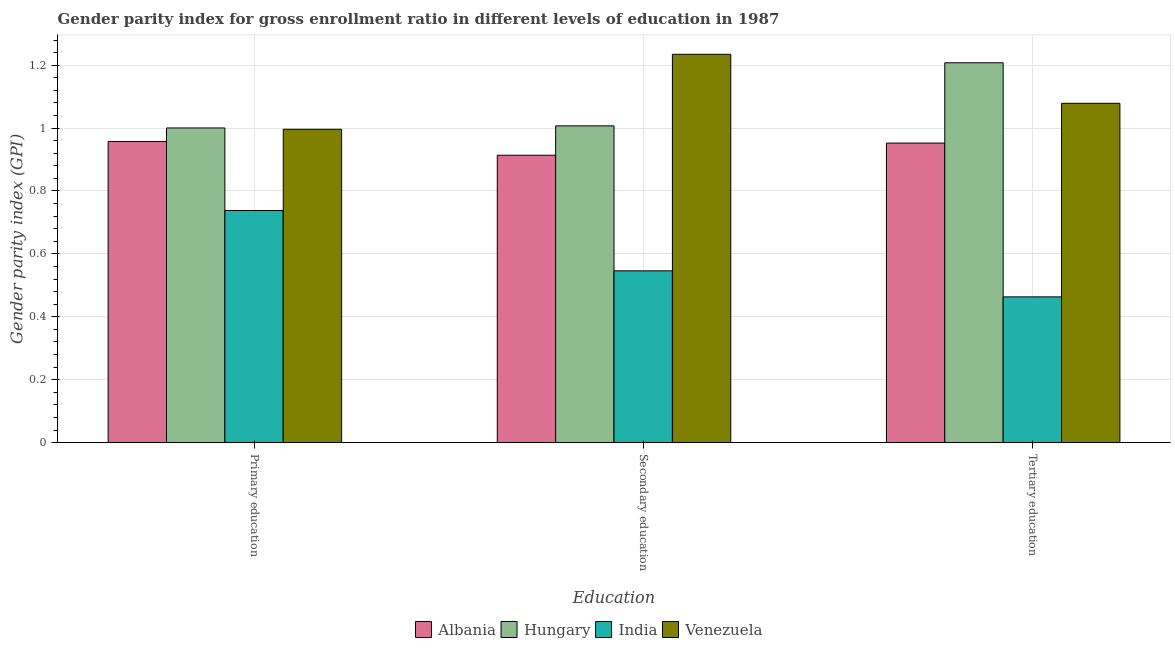How many different coloured bars are there?
Make the answer very short. 4. How many groups of bars are there?
Give a very brief answer. 3. Are the number of bars on each tick of the X-axis equal?
Provide a short and direct response. Yes. How many bars are there on the 2nd tick from the left?
Provide a succinct answer. 4. How many bars are there on the 2nd tick from the right?
Offer a terse response. 4. Across all countries, what is the maximum gender parity index in tertiary education?
Keep it short and to the point. 1.21. Across all countries, what is the minimum gender parity index in primary education?
Provide a short and direct response. 0.74. In which country was the gender parity index in tertiary education maximum?
Keep it short and to the point. Hungary. What is the total gender parity index in tertiary education in the graph?
Keep it short and to the point. 3.7. What is the difference between the gender parity index in secondary education in Albania and that in Hungary?
Provide a succinct answer. -0.09. What is the difference between the gender parity index in tertiary education in Hungary and the gender parity index in primary education in India?
Offer a very short reply. 0.47. What is the average gender parity index in primary education per country?
Your answer should be compact. 0.92. What is the difference between the gender parity index in primary education and gender parity index in tertiary education in Albania?
Give a very brief answer. 0.01. What is the ratio of the gender parity index in primary education in India to that in Albania?
Your response must be concise. 0.77. Is the gender parity index in secondary education in Venezuela less than that in Hungary?
Provide a short and direct response. No. What is the difference between the highest and the second highest gender parity index in tertiary education?
Your response must be concise. 0.13. What is the difference between the highest and the lowest gender parity index in tertiary education?
Give a very brief answer. 0.74. In how many countries, is the gender parity index in primary education greater than the average gender parity index in primary education taken over all countries?
Your answer should be very brief. 3. Is the sum of the gender parity index in secondary education in India and Venezuela greater than the maximum gender parity index in primary education across all countries?
Provide a short and direct response. Yes. What does the 3rd bar from the right in Primary education represents?
Your response must be concise. Hungary. Is it the case that in every country, the sum of the gender parity index in primary education and gender parity index in secondary education is greater than the gender parity index in tertiary education?
Keep it short and to the point. Yes. How many bars are there?
Your answer should be very brief. 12. Are all the bars in the graph horizontal?
Your answer should be compact. No. How many countries are there in the graph?
Offer a very short reply. 4. What is the difference between two consecutive major ticks on the Y-axis?
Offer a very short reply. 0.2. Are the values on the major ticks of Y-axis written in scientific E-notation?
Offer a very short reply. No. Does the graph contain any zero values?
Keep it short and to the point. No. Does the graph contain grids?
Offer a very short reply. Yes. Where does the legend appear in the graph?
Ensure brevity in your answer.  Bottom center. How are the legend labels stacked?
Your response must be concise. Horizontal. What is the title of the graph?
Give a very brief answer. Gender parity index for gross enrollment ratio in different levels of education in 1987. What is the label or title of the X-axis?
Your response must be concise. Education. What is the label or title of the Y-axis?
Give a very brief answer. Gender parity index (GPI). What is the Gender parity index (GPI) of Albania in Primary education?
Provide a short and direct response. 0.96. What is the Gender parity index (GPI) in Hungary in Primary education?
Offer a very short reply. 1. What is the Gender parity index (GPI) in India in Primary education?
Provide a short and direct response. 0.74. What is the Gender parity index (GPI) in Venezuela in Primary education?
Your answer should be very brief. 1. What is the Gender parity index (GPI) in Albania in Secondary education?
Make the answer very short. 0.91. What is the Gender parity index (GPI) in Hungary in Secondary education?
Offer a very short reply. 1.01. What is the Gender parity index (GPI) of India in Secondary education?
Offer a very short reply. 0.55. What is the Gender parity index (GPI) of Venezuela in Secondary education?
Your response must be concise. 1.23. What is the Gender parity index (GPI) of Albania in Tertiary education?
Ensure brevity in your answer.  0.95. What is the Gender parity index (GPI) of Hungary in Tertiary education?
Offer a very short reply. 1.21. What is the Gender parity index (GPI) of India in Tertiary education?
Provide a short and direct response. 0.46. What is the Gender parity index (GPI) of Venezuela in Tertiary education?
Your answer should be very brief. 1.08. Across all Education, what is the maximum Gender parity index (GPI) of Albania?
Your answer should be very brief. 0.96. Across all Education, what is the maximum Gender parity index (GPI) in Hungary?
Give a very brief answer. 1.21. Across all Education, what is the maximum Gender parity index (GPI) of India?
Your response must be concise. 0.74. Across all Education, what is the maximum Gender parity index (GPI) in Venezuela?
Your answer should be compact. 1.23. Across all Education, what is the minimum Gender parity index (GPI) in Albania?
Keep it short and to the point. 0.91. Across all Education, what is the minimum Gender parity index (GPI) of Hungary?
Offer a very short reply. 1. Across all Education, what is the minimum Gender parity index (GPI) in India?
Your answer should be compact. 0.46. Across all Education, what is the minimum Gender parity index (GPI) of Venezuela?
Offer a very short reply. 1. What is the total Gender parity index (GPI) in Albania in the graph?
Your answer should be very brief. 2.82. What is the total Gender parity index (GPI) in Hungary in the graph?
Provide a succinct answer. 3.22. What is the total Gender parity index (GPI) in India in the graph?
Make the answer very short. 1.75. What is the total Gender parity index (GPI) of Venezuela in the graph?
Provide a succinct answer. 3.31. What is the difference between the Gender parity index (GPI) in Albania in Primary education and that in Secondary education?
Provide a succinct answer. 0.04. What is the difference between the Gender parity index (GPI) of Hungary in Primary education and that in Secondary education?
Offer a terse response. -0.01. What is the difference between the Gender parity index (GPI) in India in Primary education and that in Secondary education?
Offer a terse response. 0.19. What is the difference between the Gender parity index (GPI) in Venezuela in Primary education and that in Secondary education?
Keep it short and to the point. -0.24. What is the difference between the Gender parity index (GPI) of Albania in Primary education and that in Tertiary education?
Offer a very short reply. 0.01. What is the difference between the Gender parity index (GPI) in Hungary in Primary education and that in Tertiary education?
Give a very brief answer. -0.21. What is the difference between the Gender parity index (GPI) of India in Primary education and that in Tertiary education?
Provide a short and direct response. 0.27. What is the difference between the Gender parity index (GPI) in Venezuela in Primary education and that in Tertiary education?
Provide a succinct answer. -0.08. What is the difference between the Gender parity index (GPI) in Albania in Secondary education and that in Tertiary education?
Keep it short and to the point. -0.04. What is the difference between the Gender parity index (GPI) of Hungary in Secondary education and that in Tertiary education?
Your response must be concise. -0.2. What is the difference between the Gender parity index (GPI) in India in Secondary education and that in Tertiary education?
Give a very brief answer. 0.08. What is the difference between the Gender parity index (GPI) of Venezuela in Secondary education and that in Tertiary education?
Your answer should be compact. 0.16. What is the difference between the Gender parity index (GPI) in Albania in Primary education and the Gender parity index (GPI) in Hungary in Secondary education?
Make the answer very short. -0.05. What is the difference between the Gender parity index (GPI) in Albania in Primary education and the Gender parity index (GPI) in India in Secondary education?
Your response must be concise. 0.41. What is the difference between the Gender parity index (GPI) in Albania in Primary education and the Gender parity index (GPI) in Venezuela in Secondary education?
Offer a very short reply. -0.28. What is the difference between the Gender parity index (GPI) of Hungary in Primary education and the Gender parity index (GPI) of India in Secondary education?
Make the answer very short. 0.45. What is the difference between the Gender parity index (GPI) in Hungary in Primary education and the Gender parity index (GPI) in Venezuela in Secondary education?
Keep it short and to the point. -0.23. What is the difference between the Gender parity index (GPI) in India in Primary education and the Gender parity index (GPI) in Venezuela in Secondary education?
Provide a succinct answer. -0.5. What is the difference between the Gender parity index (GPI) of Albania in Primary education and the Gender parity index (GPI) of Hungary in Tertiary education?
Ensure brevity in your answer.  -0.25. What is the difference between the Gender parity index (GPI) in Albania in Primary education and the Gender parity index (GPI) in India in Tertiary education?
Make the answer very short. 0.49. What is the difference between the Gender parity index (GPI) of Albania in Primary education and the Gender parity index (GPI) of Venezuela in Tertiary education?
Make the answer very short. -0.12. What is the difference between the Gender parity index (GPI) in Hungary in Primary education and the Gender parity index (GPI) in India in Tertiary education?
Ensure brevity in your answer.  0.54. What is the difference between the Gender parity index (GPI) in Hungary in Primary education and the Gender parity index (GPI) in Venezuela in Tertiary education?
Provide a succinct answer. -0.08. What is the difference between the Gender parity index (GPI) of India in Primary education and the Gender parity index (GPI) of Venezuela in Tertiary education?
Your answer should be compact. -0.34. What is the difference between the Gender parity index (GPI) in Albania in Secondary education and the Gender parity index (GPI) in Hungary in Tertiary education?
Provide a succinct answer. -0.29. What is the difference between the Gender parity index (GPI) in Albania in Secondary education and the Gender parity index (GPI) in India in Tertiary education?
Your answer should be compact. 0.45. What is the difference between the Gender parity index (GPI) in Albania in Secondary education and the Gender parity index (GPI) in Venezuela in Tertiary education?
Your answer should be very brief. -0.17. What is the difference between the Gender parity index (GPI) of Hungary in Secondary education and the Gender parity index (GPI) of India in Tertiary education?
Keep it short and to the point. 0.54. What is the difference between the Gender parity index (GPI) in Hungary in Secondary education and the Gender parity index (GPI) in Venezuela in Tertiary education?
Your answer should be very brief. -0.07. What is the difference between the Gender parity index (GPI) in India in Secondary education and the Gender parity index (GPI) in Venezuela in Tertiary education?
Your response must be concise. -0.53. What is the average Gender parity index (GPI) of Albania per Education?
Provide a short and direct response. 0.94. What is the average Gender parity index (GPI) of Hungary per Education?
Provide a short and direct response. 1.07. What is the average Gender parity index (GPI) in India per Education?
Offer a terse response. 0.58. What is the average Gender parity index (GPI) in Venezuela per Education?
Make the answer very short. 1.1. What is the difference between the Gender parity index (GPI) of Albania and Gender parity index (GPI) of Hungary in Primary education?
Provide a succinct answer. -0.04. What is the difference between the Gender parity index (GPI) in Albania and Gender parity index (GPI) in India in Primary education?
Make the answer very short. 0.22. What is the difference between the Gender parity index (GPI) in Albania and Gender parity index (GPI) in Venezuela in Primary education?
Provide a succinct answer. -0.04. What is the difference between the Gender parity index (GPI) of Hungary and Gender parity index (GPI) of India in Primary education?
Ensure brevity in your answer.  0.26. What is the difference between the Gender parity index (GPI) in Hungary and Gender parity index (GPI) in Venezuela in Primary education?
Your response must be concise. 0. What is the difference between the Gender parity index (GPI) of India and Gender parity index (GPI) of Venezuela in Primary education?
Your response must be concise. -0.26. What is the difference between the Gender parity index (GPI) of Albania and Gender parity index (GPI) of Hungary in Secondary education?
Provide a short and direct response. -0.09. What is the difference between the Gender parity index (GPI) in Albania and Gender parity index (GPI) in India in Secondary education?
Your answer should be compact. 0.37. What is the difference between the Gender parity index (GPI) in Albania and Gender parity index (GPI) in Venezuela in Secondary education?
Your answer should be compact. -0.32. What is the difference between the Gender parity index (GPI) of Hungary and Gender parity index (GPI) of India in Secondary education?
Your response must be concise. 0.46. What is the difference between the Gender parity index (GPI) in Hungary and Gender parity index (GPI) in Venezuela in Secondary education?
Offer a very short reply. -0.23. What is the difference between the Gender parity index (GPI) in India and Gender parity index (GPI) in Venezuela in Secondary education?
Provide a short and direct response. -0.69. What is the difference between the Gender parity index (GPI) of Albania and Gender parity index (GPI) of Hungary in Tertiary education?
Your response must be concise. -0.26. What is the difference between the Gender parity index (GPI) in Albania and Gender parity index (GPI) in India in Tertiary education?
Your answer should be compact. 0.49. What is the difference between the Gender parity index (GPI) of Albania and Gender parity index (GPI) of Venezuela in Tertiary education?
Your answer should be compact. -0.13. What is the difference between the Gender parity index (GPI) of Hungary and Gender parity index (GPI) of India in Tertiary education?
Keep it short and to the point. 0.74. What is the difference between the Gender parity index (GPI) in Hungary and Gender parity index (GPI) in Venezuela in Tertiary education?
Your answer should be very brief. 0.13. What is the difference between the Gender parity index (GPI) in India and Gender parity index (GPI) in Venezuela in Tertiary education?
Make the answer very short. -0.62. What is the ratio of the Gender parity index (GPI) in Albania in Primary education to that in Secondary education?
Your response must be concise. 1.05. What is the ratio of the Gender parity index (GPI) in Hungary in Primary education to that in Secondary education?
Provide a short and direct response. 0.99. What is the ratio of the Gender parity index (GPI) of India in Primary education to that in Secondary education?
Make the answer very short. 1.35. What is the ratio of the Gender parity index (GPI) of Venezuela in Primary education to that in Secondary education?
Keep it short and to the point. 0.81. What is the ratio of the Gender parity index (GPI) in Hungary in Primary education to that in Tertiary education?
Make the answer very short. 0.83. What is the ratio of the Gender parity index (GPI) in India in Primary education to that in Tertiary education?
Ensure brevity in your answer.  1.59. What is the ratio of the Gender parity index (GPI) of Venezuela in Primary education to that in Tertiary education?
Make the answer very short. 0.92. What is the ratio of the Gender parity index (GPI) of Albania in Secondary education to that in Tertiary education?
Offer a very short reply. 0.96. What is the ratio of the Gender parity index (GPI) of Hungary in Secondary education to that in Tertiary education?
Provide a short and direct response. 0.83. What is the ratio of the Gender parity index (GPI) of India in Secondary education to that in Tertiary education?
Keep it short and to the point. 1.18. What is the ratio of the Gender parity index (GPI) of Venezuela in Secondary education to that in Tertiary education?
Keep it short and to the point. 1.14. What is the difference between the highest and the second highest Gender parity index (GPI) of Albania?
Ensure brevity in your answer.  0.01. What is the difference between the highest and the second highest Gender parity index (GPI) in Hungary?
Your answer should be compact. 0.2. What is the difference between the highest and the second highest Gender parity index (GPI) in India?
Give a very brief answer. 0.19. What is the difference between the highest and the second highest Gender parity index (GPI) in Venezuela?
Give a very brief answer. 0.16. What is the difference between the highest and the lowest Gender parity index (GPI) in Albania?
Your answer should be compact. 0.04. What is the difference between the highest and the lowest Gender parity index (GPI) of Hungary?
Your answer should be very brief. 0.21. What is the difference between the highest and the lowest Gender parity index (GPI) in India?
Offer a very short reply. 0.27. What is the difference between the highest and the lowest Gender parity index (GPI) of Venezuela?
Offer a very short reply. 0.24. 